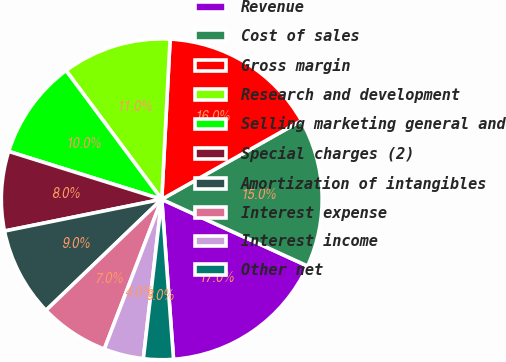Convert chart to OTSL. <chart><loc_0><loc_0><loc_500><loc_500><pie_chart><fcel>Revenue<fcel>Cost of sales<fcel>Gross margin<fcel>Research and development<fcel>Selling marketing general and<fcel>Special charges (2)<fcel>Amortization of intangibles<fcel>Interest expense<fcel>Interest income<fcel>Other net<nl><fcel>17.0%<fcel>15.0%<fcel>16.0%<fcel>11.0%<fcel>10.0%<fcel>8.0%<fcel>9.0%<fcel>7.0%<fcel>4.0%<fcel>3.0%<nl></chart> 